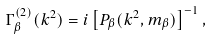<formula> <loc_0><loc_0><loc_500><loc_500>\Gamma _ { \beta } ^ { ( 2 ) } ( k ^ { 2 } ) = i \left [ P _ { \beta } ( k ^ { 2 } , m _ { \beta } ) \right ] ^ { - 1 } ,</formula> 